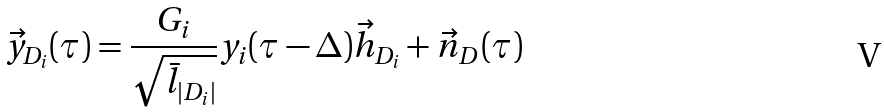<formula> <loc_0><loc_0><loc_500><loc_500>\vec { y } _ { D _ { i } } ( \tau ) = \frac { G _ { i } } { \sqrt { \bar { l } _ { | D _ { i } | } } } y _ { i } ( \tau - \Delta ) { \vec { h } } _ { D _ { i } } + { \vec { n } } _ { D } ( \tau )</formula> 